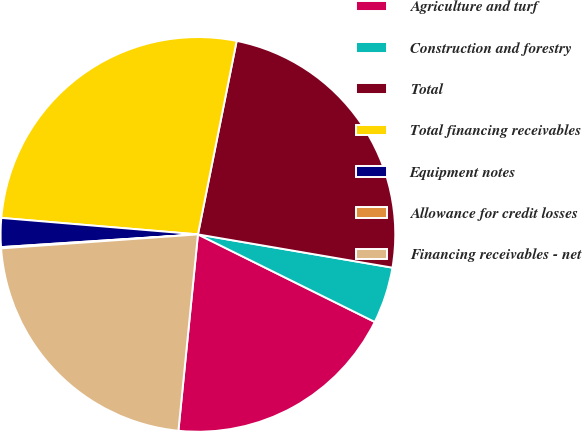Convert chart. <chart><loc_0><loc_0><loc_500><loc_500><pie_chart><fcel>Agriculture and turf<fcel>Construction and forestry<fcel>Total<fcel>Total financing receivables<fcel>Equipment notes<fcel>Allowance for credit losses<fcel>Financing receivables - net<nl><fcel>19.26%<fcel>4.62%<fcel>24.55%<fcel>26.81%<fcel>2.36%<fcel>0.1%<fcel>22.29%<nl></chart> 